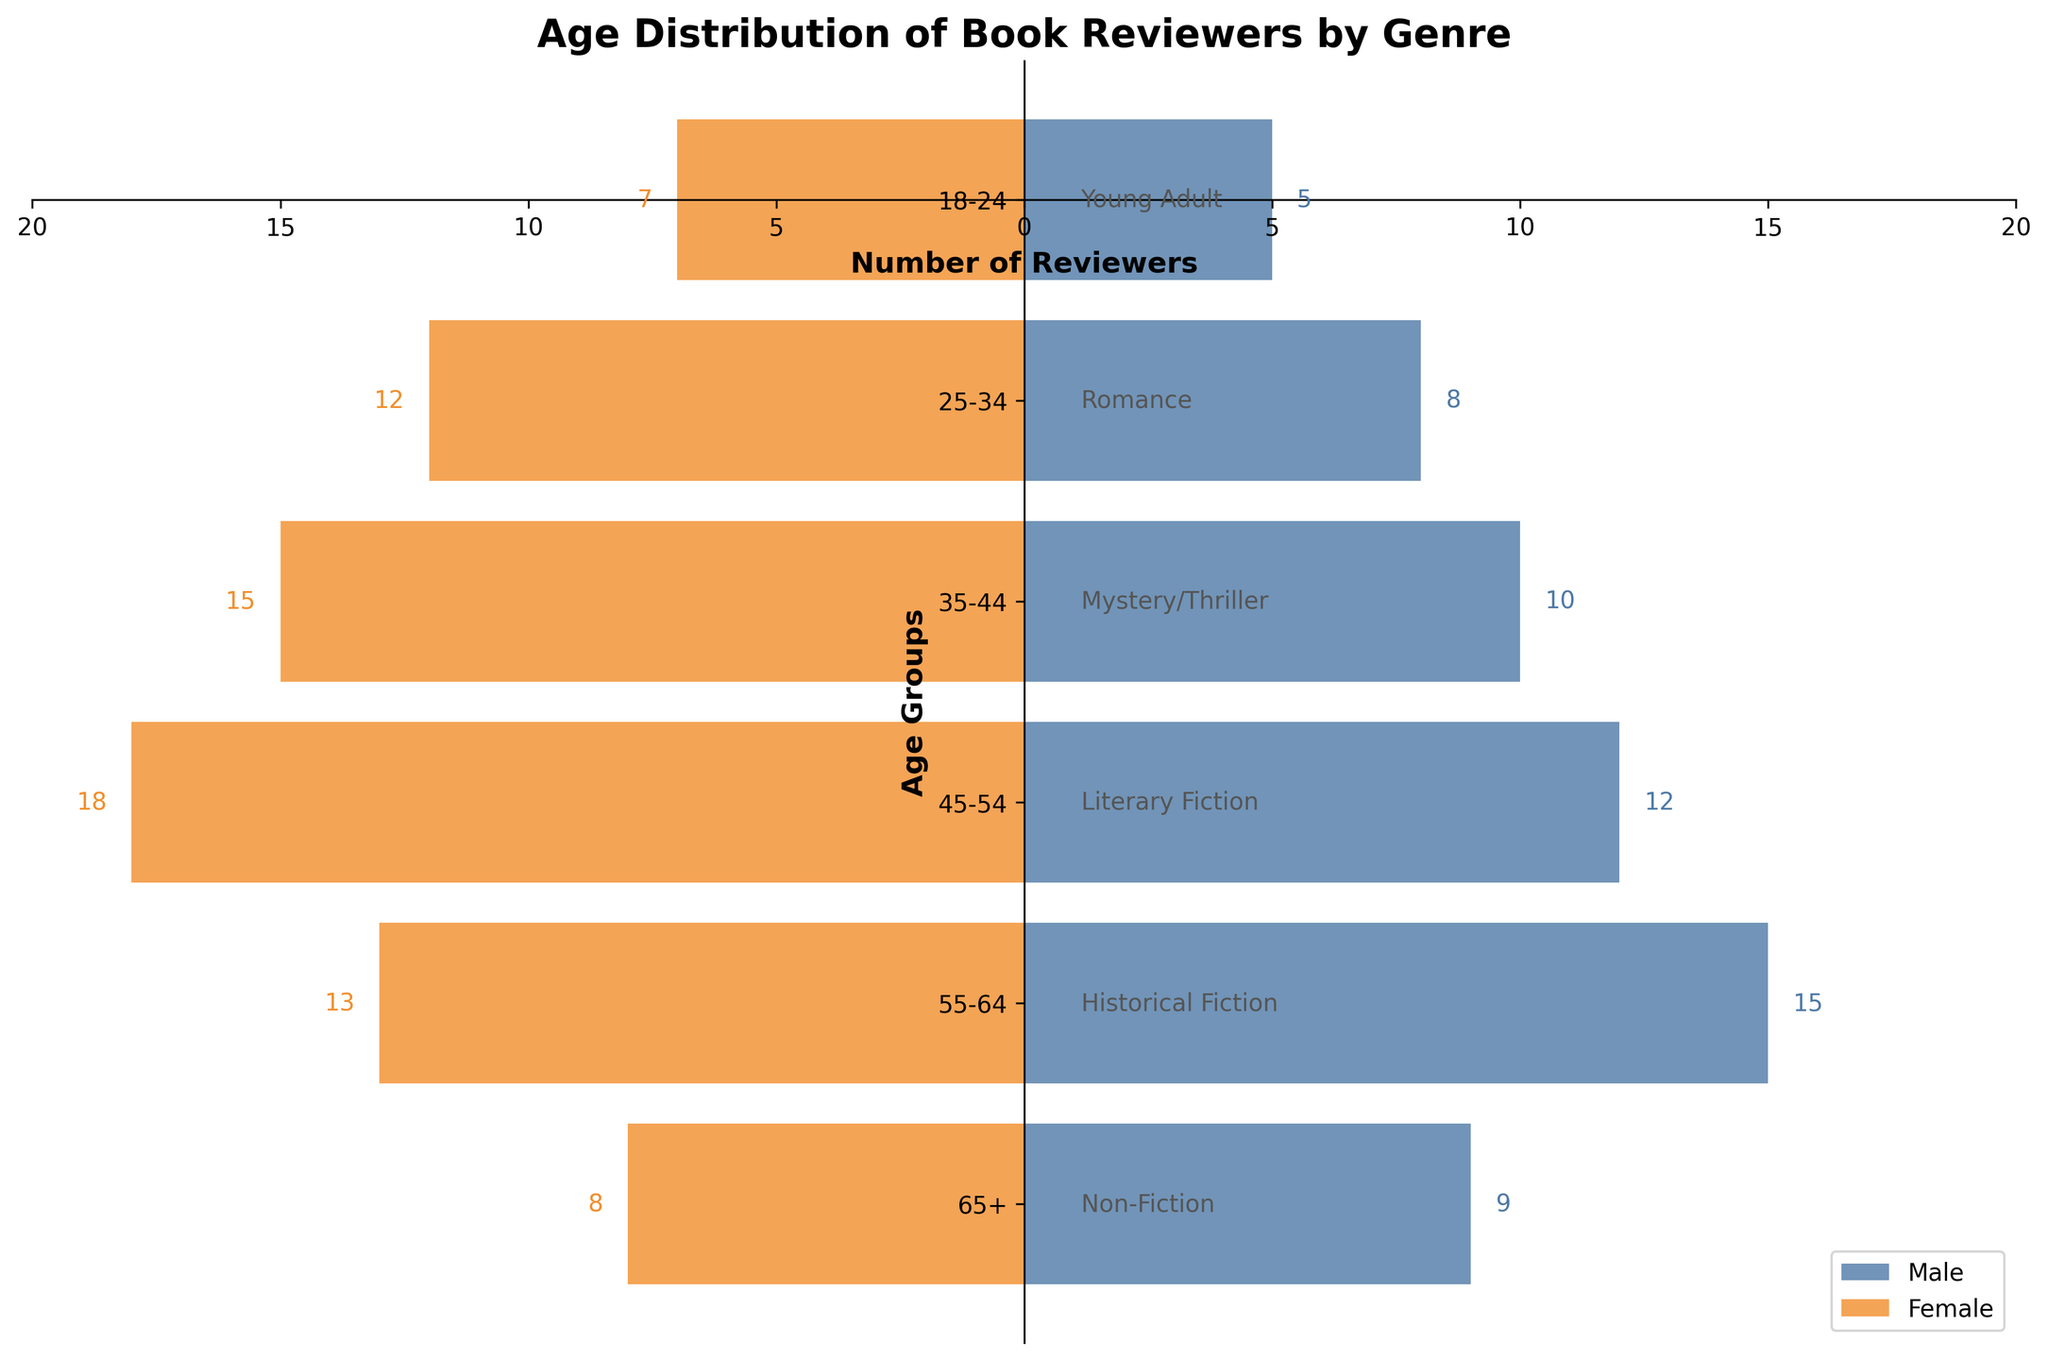What is the total number of male reviewers in the 18-24 age group? The figure shows that there are 5 male reviewers in the 18-24 age group.
Answer: 5 What age group has the highest number of female reviewers in the Romance genre? For the Romance genre, the figure shows the 25-34 age group with 12 female reviewers.
Answer: 25-34 Which genre has more male reviewers than female reviewers? By examining the bars, the Historical Fiction genre (55-64 age group) has 15 male reviewers and 13 female reviewers, indicating there are more male reviewers than female reviewers.
Answer: Historical Fiction Which age group has the smallest difference between male and female reviewers? The difference in the 65+ age group is 1 (9 male and 8 female). All other age groups have a larger difference.
Answer: 65+ How many total reviewers are there in the 35-44 age group for the Mystery/Thriller genre? Summing the male (10) and female (15) reviewers for the Mystery/Thriller genre, the total is 25.
Answer: 25 Which genre has the highest combined number of reviewers? Literary Fiction (45-54 age group) has the highest combined total with 30 reviewers (12 male + 18 female).
Answer: Literary Fiction How many more female reviewers are there in the Romance genre compared to the Young Adult genre? The Romance genre has 12 female reviewers and the Young Adult genre has 7 female reviewers. The difference is 12 - 7 = 5.
Answer: 5 Compare the number of reviewers in the 55-64 age group. Which gender has more reviewers and by how much? In the 55-64 age group, there are 15 male reviewers and 13 female reviewers. Males have 2 more reviewers than females (15 - 13 = 2).
Answer: Male, 2 Which age group has the most balanced number of male and female reviewers? The 65+ age group has 9 male and 8 female reviewers, making it the most balanced.
Answer: 65+ What is the total number of female reviewers across all genres? Adding the number of female reviewers: 7 (Young Adult) + 12 (Romance) + 15 (Mystery/Thriller) + 18 (Literary Fiction) + 13 (Historical Fiction) + 8 (Non-Fiction) = 73.
Answer: 73 